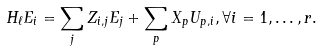<formula> <loc_0><loc_0><loc_500><loc_500>H _ { \ell } E _ { i } = \sum _ { j } Z _ { i , j } E _ { j } + \sum _ { p } X _ { p } U _ { p , i } , \forall i = 1 , \dots , r .</formula> 